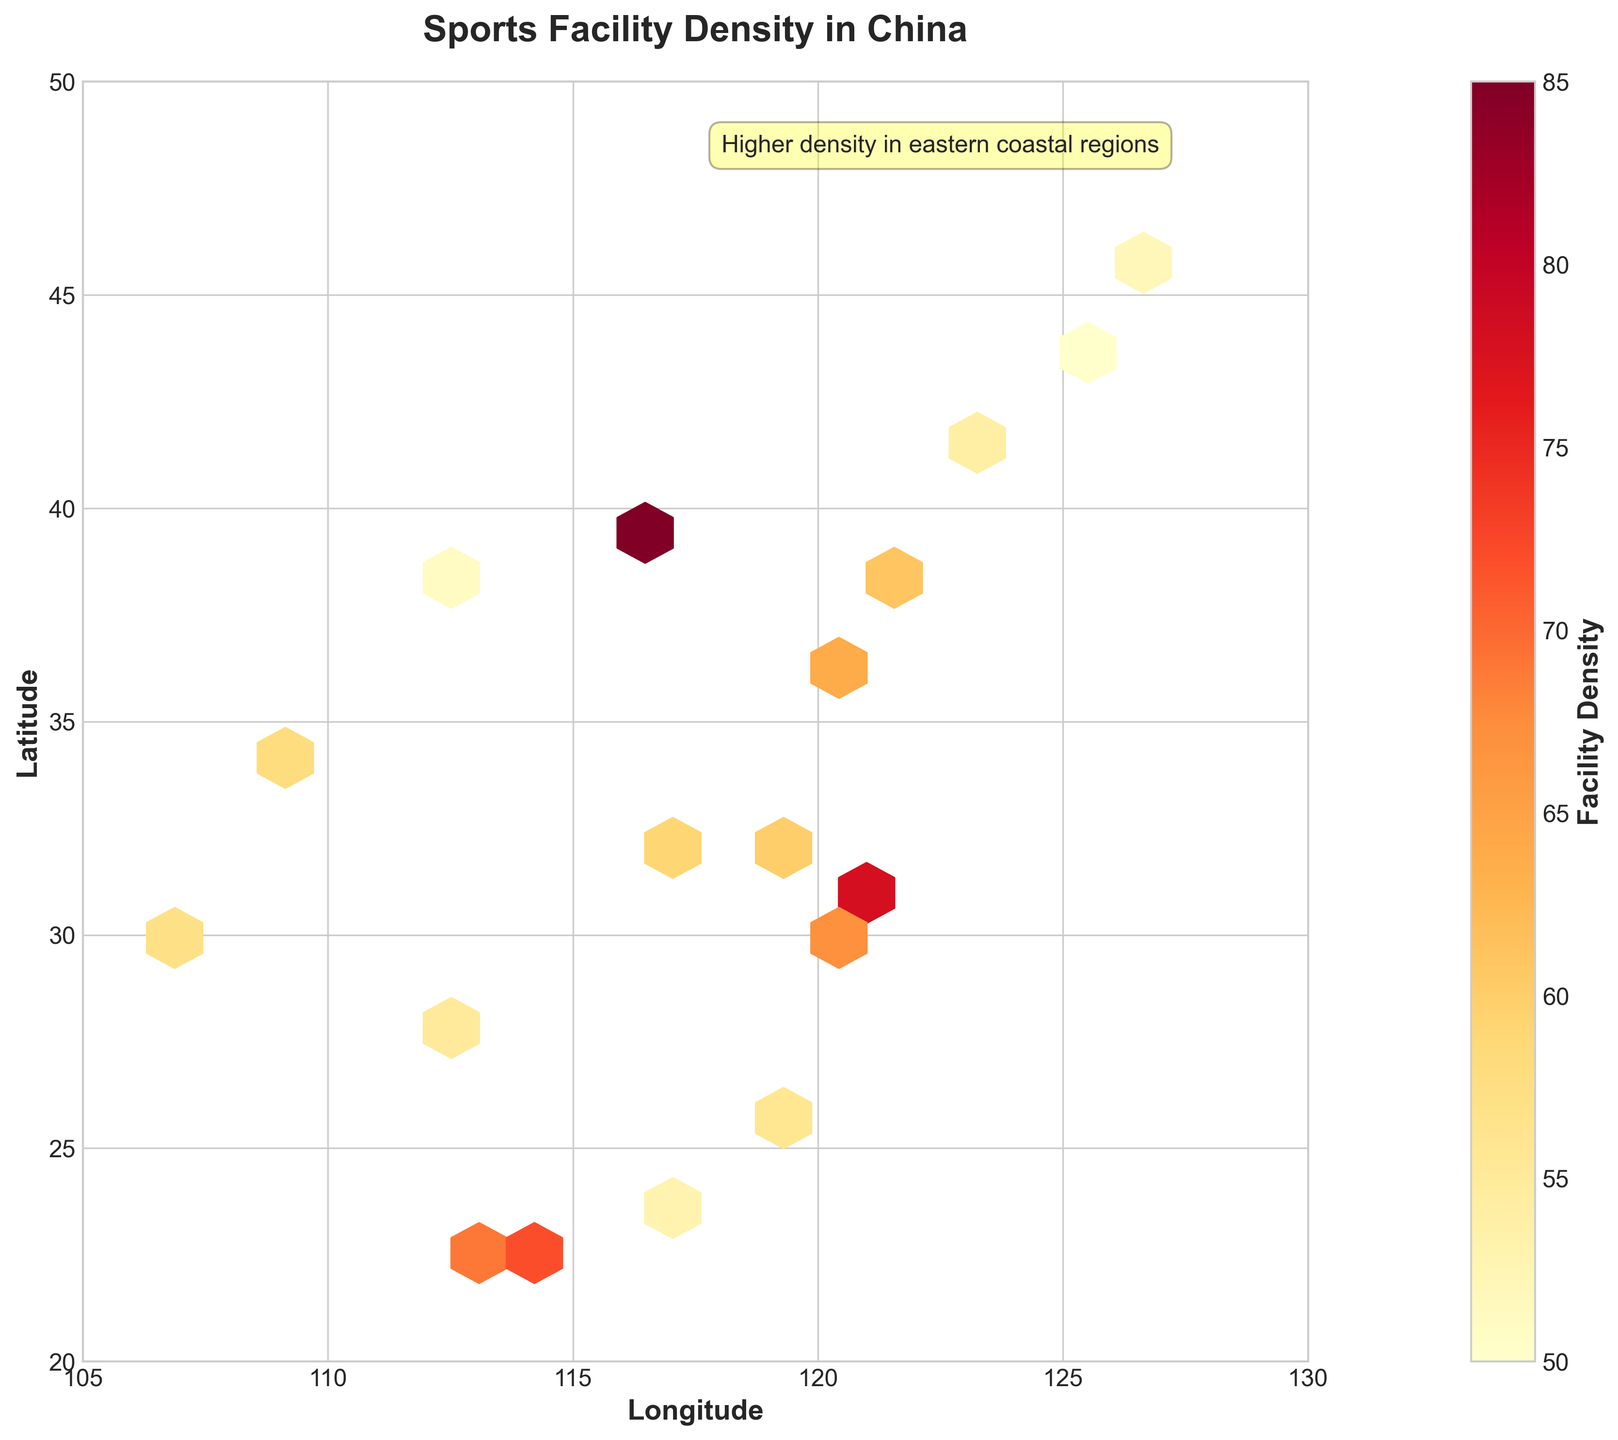How many levels of facility density does the colorbar display? The colorbar represents the range of facility density through different colors. To determine the number of levels, visually inspect the colorbar from its lowest to highest values.
Answer: Multiple levels What is the general trend of facility density in eastern coastal regions? The annotation on the figure states "Higher density in eastern coastal regions," which suggests that these regions show higher densities. Visually inspecting the plot also confirms more intense colors in the eastern coastal areas.
Answer: Higher density Which region has the highest facility density, and what is its value? By looking at the darkest hexbin on the plot and cross-referencing the latitude and longitude grid, one can identify the region. According to the data, the highest density is in Beijing (39.9042, 116.4074) with a value of 85.
Answer: Beijing, 85 Are there any regions with a very low facility density below 54? Reviewing the color-coded density and cross-referencing the values on the colorbar with the geographical plots, the regions at or below 54 are Shenyang and Changchun with densities of 54 and 50 respectively.
Answer: Shenyang and Changchun How is the facility density distributed across China in terms of latitude? By examining the latitude axis and noting where higher and lower density regions lie, we observe higher densities generally in mid-latitudes (around 22-40 degrees) and fewer densities in more northern and southern extremes.
Answer: Higher in mid-latitudes Which regions fall in the 56-70 density range? By matching hexbin colors within the range of 56 to 70 on the colorbar to specific geographic areas, cities such as Guangzhou, Wuhan, and Hangzhou fall within this range.
Answer: Guangzhou, Wuhan, Hangzhou Compare the facility density between Chongqing and Suzhou. Which one has a higher density? The figure shows the density values for each point; by cross-referencing the locations, we see that Chongqing (57) has a lower density compared to Suzhou (60).
Answer: Suzhou What is the approximate range of facility density values shown in the colorbar? The range can be observed by noting the lowest and highest values on the colorbar scale displayed on the right side of the plot.
Answer: Approximately 50 to 85 Do any regions in northeastern China have moderate facility density? Reviewing the plot for the northeastern area (around 120 longitude and 45 latitude) shows regions like Harbin with densities in the middle range of the color spectrum (52), indicating moderate density.
Answer: Yes, Harbin 